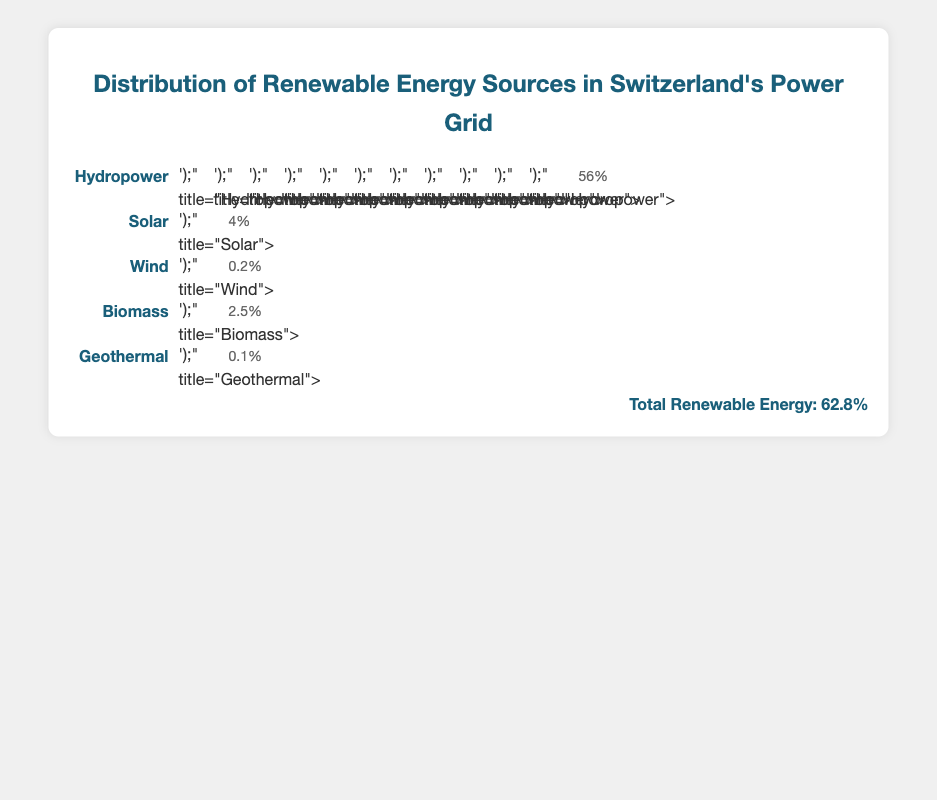What percentage of Switzerland's renewable energy comes from solar power? The figure shows that the icon for solar power represents 4% of the renewable energy sources in Switzerland's power grid.
Answer: 4% How many icons represent wind energy, and what is its percentage in the power grid? There is 1 icon representing wind energy, which corresponds to 0.2% of the renewable energy sources.
Answer: 1, 0.2% What type of renewable energy has the highest percentage in Switzerland's power grid? By observing the figure, it shows that hydropower has the highest percentage with 56%.
Answer: Hydropower Combine the percentages for solar, wind, biomass, and geothermal energy. What is the total? Sum the percentages: 4% (solar) + 0.2% (wind) + 2.5% (biomass) + 0.1% (geothermal) = 6.8%.
Answer: 6.8% Compare the number of icons representing hydropower and solar power. How many more icons does hydropower have compared to solar power? Hydropower has 11 icons and solar has 1. The difference is 11 - 1 = 10 icons.
Answer: 10 How does the percentage of biomass energy compare to that of geothermal energy? Biomass energy is 2.5% while geothermal energy is 0.1%. Therefore, biomass energy is 2.5% - 0.1% = 2.4% higher than geothermal.
Answer: 2.4% higher What is the total number of icons used to represent all the renewable energy sources in the figure? The icons from each source are: hydropower (11), solar (1), wind (1), biomass (1), geothermal (1). The total is 11 + 1 + 1 + 1 + 1 = 15 icons.
Answer: 15 Given that the value of each icon is 5%, how many icons in total would represent the entire power grid (100%)? Each icon represents 5%, so 100% divided by 5% per icon equals 20 icons.
Answer: 20 